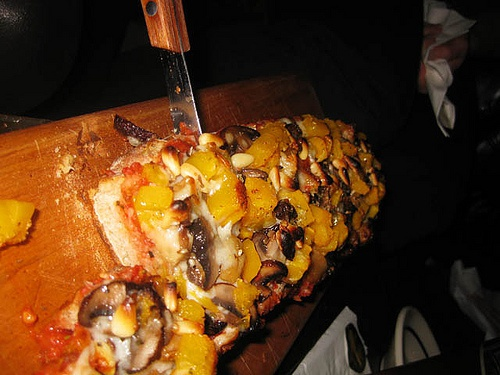Describe the objects in this image and their specific colors. I can see pizza in black, brown, orange, and maroon tones, knife in black, maroon, and brown tones, and bowl in black and gray tones in this image. 